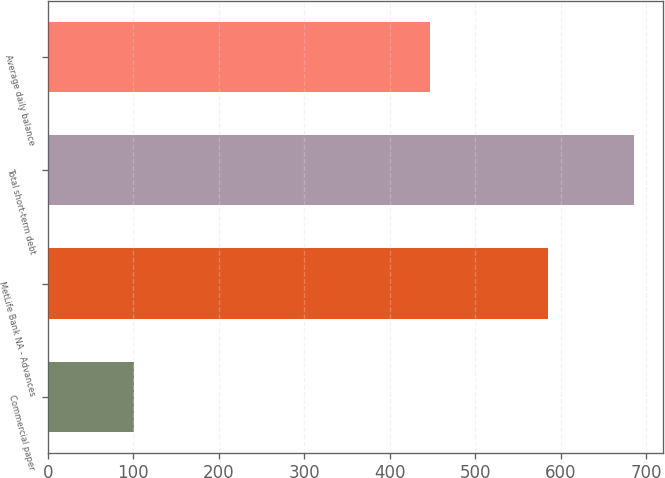Convert chart to OTSL. <chart><loc_0><loc_0><loc_500><loc_500><bar_chart><fcel>Commercial paper<fcel>MetLife Bank NA - Advances<fcel>Total short-term debt<fcel>Average daily balance<nl><fcel>101<fcel>585<fcel>686<fcel>447<nl></chart> 